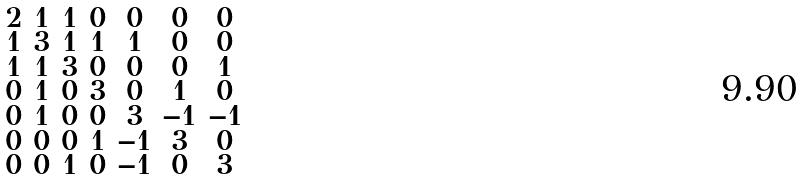<formula> <loc_0><loc_0><loc_500><loc_500>\begin{smallmatrix} 2 & 1 & 1 & 0 & 0 & 0 & 0 \\ 1 & 3 & 1 & 1 & 1 & 0 & 0 \\ 1 & 1 & 3 & 0 & 0 & 0 & 1 \\ 0 & 1 & 0 & 3 & 0 & 1 & 0 \\ 0 & 1 & 0 & 0 & 3 & - 1 & - 1 \\ 0 & 0 & 0 & 1 & - 1 & 3 & 0 \\ 0 & 0 & 1 & 0 & - 1 & 0 & 3 \end{smallmatrix}</formula> 